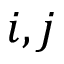<formula> <loc_0><loc_0><loc_500><loc_500>i , j</formula> 